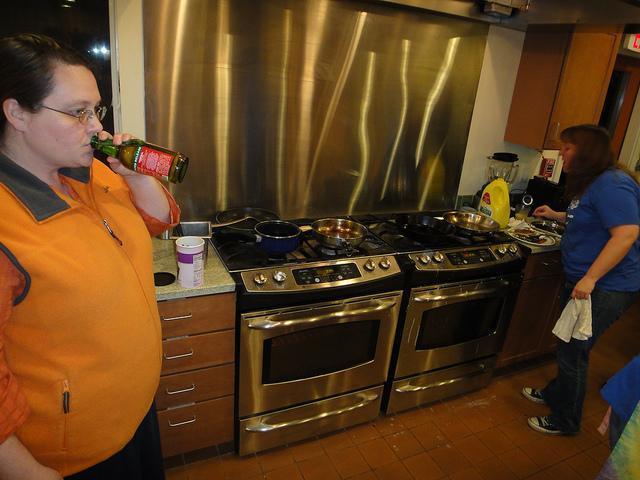How many stoves are there?
Give a very brief answer. 2. How many dishtowels are on the stove?
Give a very brief answer. 0. How many shirt are there?
Give a very brief answer. 2. How many pairs of shoes?
Give a very brief answer. 1. How many men are in the picture?
Give a very brief answer. 0. How many animals are on the floor?
Give a very brief answer. 0. How many pizza's are on the cutting board?
Give a very brief answer. 0. How many people?
Give a very brief answer. 2. How many piercings does the girl have in her ear?
Give a very brief answer. 0. How many shoes can you see?
Give a very brief answer. 2. How many people are in the picture?
Give a very brief answer. 2. How many women are visible in the background?
Give a very brief answer. 1. How many people can be seen?
Give a very brief answer. 3. How many ovens are there?
Give a very brief answer. 2. How many skateboard wheels are there?
Give a very brief answer. 0. 